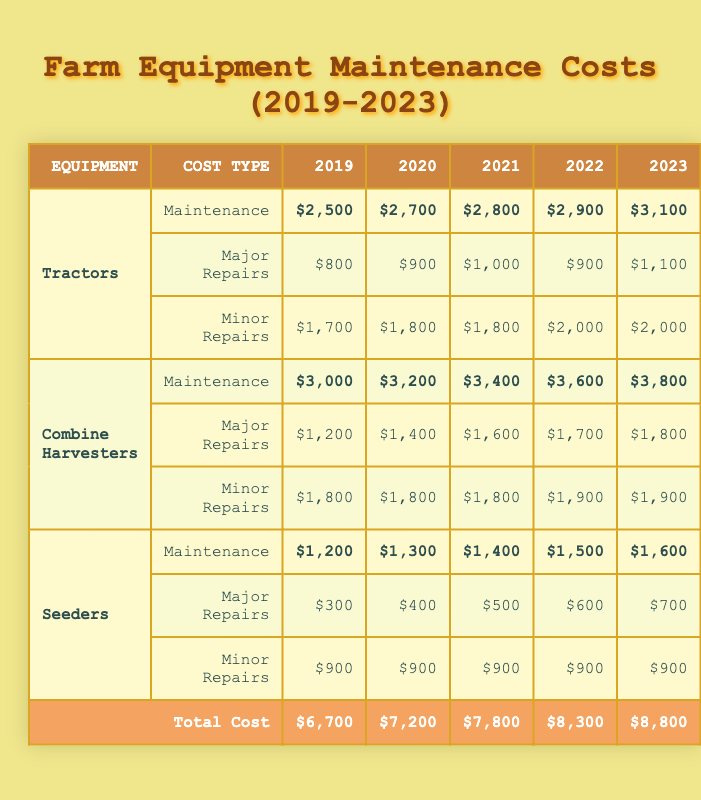What was the total maintenance cost for 2022? The total maintenance cost for 2022 is directly listed in the table under the "Total Cost" row, which indicates $8,300.
Answer: $8,300 Which year had the highest total maintenance cost? By examining the "Total Cost" column, the highest value is in 2023, which shows as $8,800.
Answer: 2023 What was the maintenance cost for tractors in 2021? The maintenance cost for tractors is shown under the "Maintenance" row for 2021, which is $2,800.
Answer: $2,800 How much did we spend on major repairs for seeders in 2020? The major repair cost for seeders in 2020 is directly listed as $400 in the corresponding row and column.
Answer: $400 What is the difference in maintenance costs for combine harvesters between 2019 and 2023? The maintenance cost for combine harvesters in 2019 is $3,000 and in 2023 is $3,800. The difference is $3,800 - $3,000 = $800.
Answer: $800 What is the average maintenance cost for tractors over the five years? The tractor maintenance costs for the five years are $2,500, $2,700, $2,800, $2,900, and $3,100. The total is $2,500 + $2,700 + $2,800 + $2,900 + $3,100 = $14,000, and the average is $14,000 / 5 = $2,800.
Answer: $2,800 Did the costs for minor repairs on seeders increase every year? Looking at the minor repair costs for seeders: $900 in 2019, $900 in 2020, $900 in 2021, $900 in 2022, and $900 in 2023, the costs have remained constant, so the answer is no.
Answer: No Which type of equipment had the lowest total maintenance cost in 2021? The total maintenance costs for each equipment type in 2021 are: Tractors $2,800, Combine Harvesters $3,400, and Seeders $1,400. Seeders have the lowest total maintenance cost.
Answer: Seeders What was the total amount spent on major repairs across all equipment in 2020? For 2020, the major repairs costs are Tractors $900, Combine Harvesters $1,400, and Seeders $400. The total is $900 + $1,400 + $400 = $2,700.
Answer: $2,700 Was the cost of maintenance for tractors higher in 2023 than it was in 2019? The tractor maintenance cost in 2023 is $3,100, while in 2019 it was $2,500. Since $3,100 is greater than $2,500, the answer is yes.
Answer: Yes 